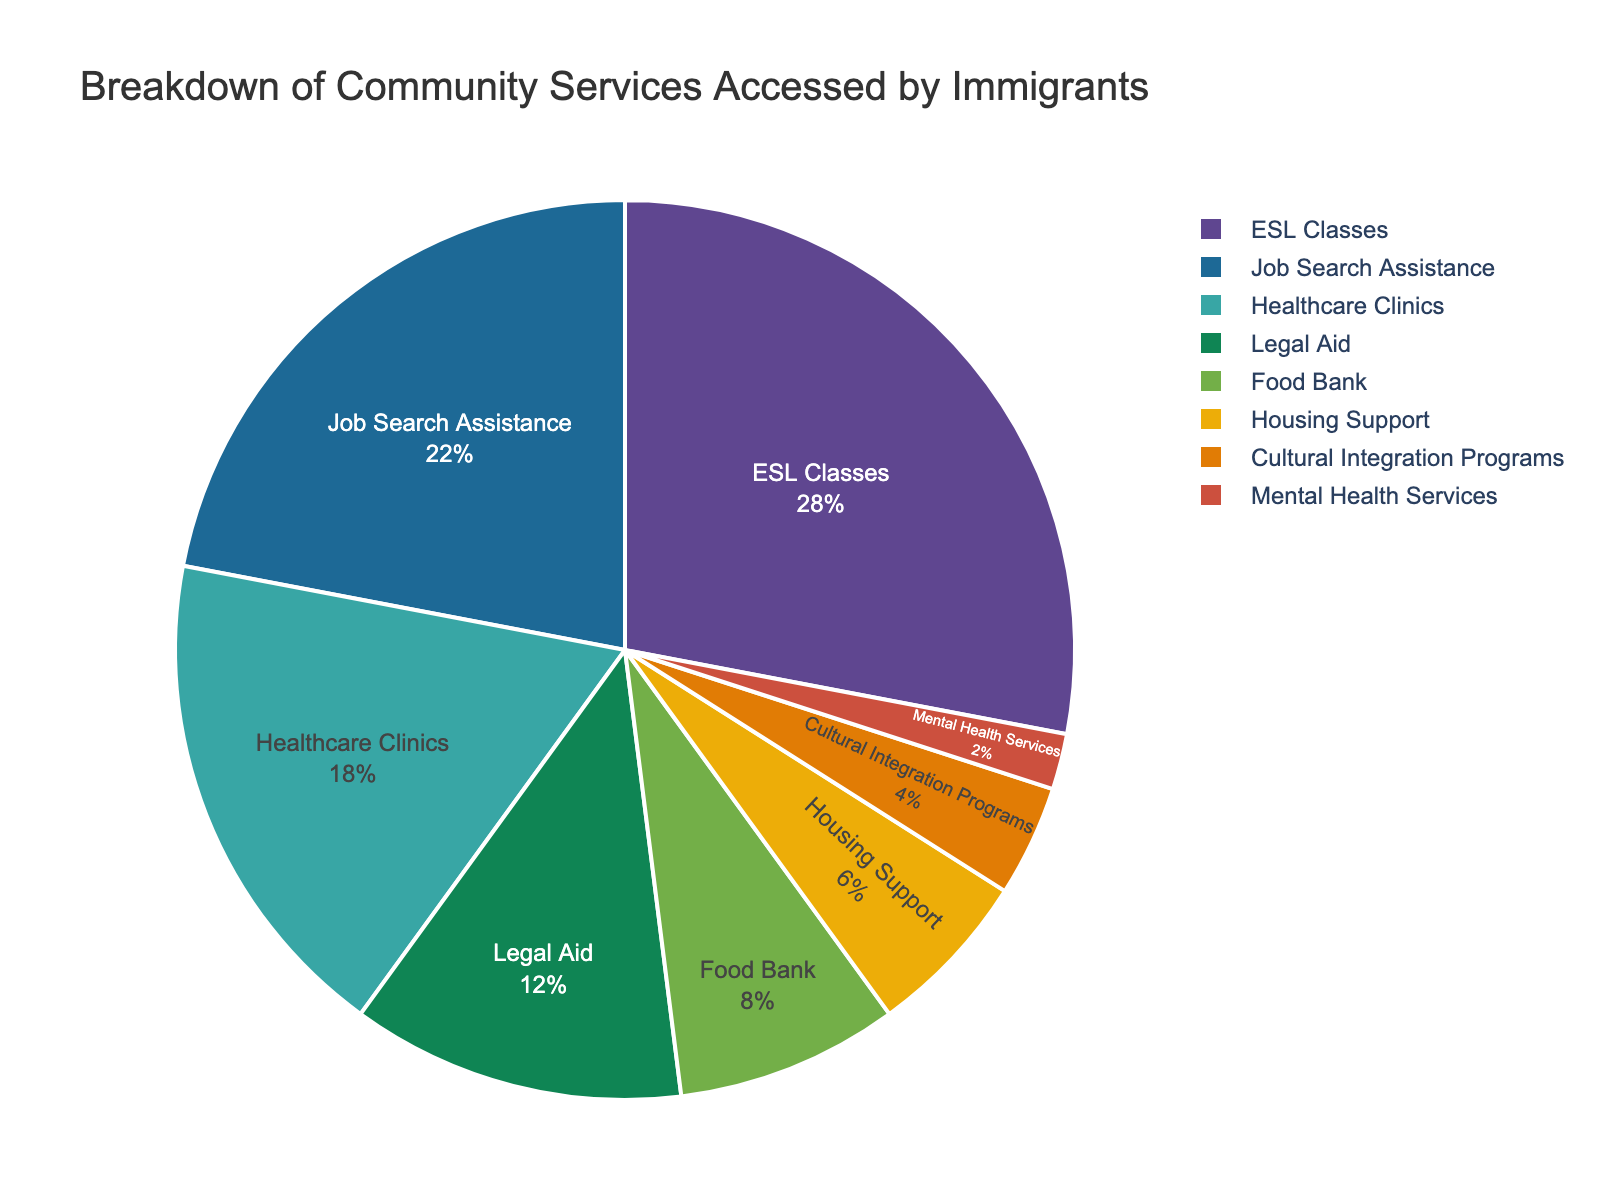What percentage of immigrants accessed ESL Classes? The pie chart indicates that the segment for ESL Classes is labeled with its percentage. By directly observing this section of the pie chart, we see that it is marked as 28%.
Answer: 28% Which service was accessed the least by immigrants? To find the least accessed service, look for the smallest segment in the pie chart. The smallest segment is Mental Health Services.
Answer: Mental Health Services What is the combined percentage of immigrants accessing Healthcare Clinics and Job Search Assistance? To find the combined percentage, add the individual percentages for Healthcare Clinics and Job Search Assistance. From the chart, these percentages are 18% and 22% respectively. Adding them together, we get 18% + 22% = 40%.
Answer: 40% Compare the usage of Legal Aid services to Housing Support. Which one was accessed more and by what percentage difference? First, identify the percentages for Legal Aid and Housing Support from the pie chart, which are 12% and 6% respectively. Then, subtract the percentage of Housing Support from Legal Aid: 12% - 6% = 6%. Legal Aid was accessed more by 6%.
Answer: Legal Aid, 6% What is the cumulative percentage of services accessed that are greater than or equal to 10%? Add the percentages of all services with a value greater than or equal to 10%. These services are ESL Classes (28%), Job Search Assistance (22%), and Healthcare Clinics (18%), and Legal Aid (12%). Summing these, we get 28% + 22% + 18% + 12% = 80%.
Answer: 80% How much more popular are Food Bank services compared to Cultural Integration Programs? Identify the percentages for Food Bank and Cultural Integration Programs from the pie chart, which are 8% and 4% respectively. Subtract the percentage of Cultural Integration Programs from Food Bank: 8% - 4% = 4%.
Answer: 4% If Mental Health Services and Cultural Integration Programs combined were to be visualized as a single segment, what would its percentage be? Add the individual percentages of Mental Health Services and Cultural Integration Programs. From the chart, these percentages are 2% and 4% respectively. Adding them together, we get 2% + 4% = 6%.
Answer: 6% Which services together constitute exactly half of the total community services accessed by immigrants? Identify and combine services until the total percentage reaches 50%. From the chart, ESL Classes (28%) and Job Search Assistance (22%) together make 28% + 22% = 50%.
Answer: ESL Classes and Job Search Assistance What is the difference in percentage between the most accessed service and the least accessed service? Identify the most accessed service, ESL Classes (28%), and the least accessed service, Mental Health Services (2%). Subtract the smallest value from the largest: 28% - 2% = 26%.
Answer: 26% By what percentage do ESL Classes surpass Healthcare Clinics usage? Identify the percentages for ESL Classes and Healthcare Clinics from the pie chart, which are 28% and 18% respectively. Subtract the percentage of Healthcare Clinics from ESL Classes: 28% - 18% = 10%.
Answer: 10% 